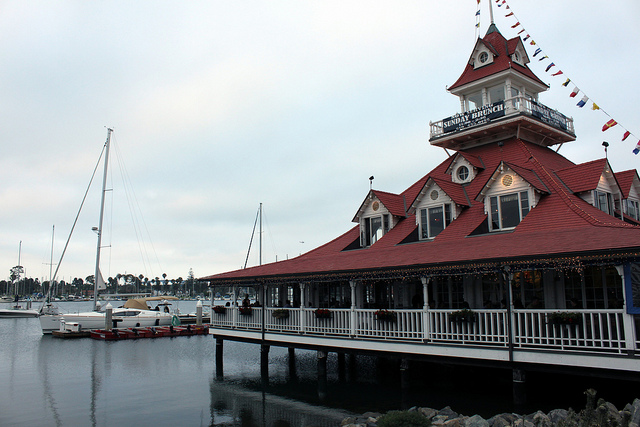Identify and read out the text in this image. BRUNCH SUNDAY 